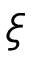<formula> <loc_0><loc_0><loc_500><loc_500>\xi</formula> 